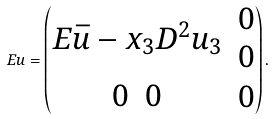<formula> <loc_0><loc_0><loc_500><loc_500>E u = \begin{pmatrix} \begin{matrix} E \bar { u } - x _ { 3 } D ^ { 2 } u _ { 3 } \end{matrix} & \begin{matrix} 0 \\ 0 \end{matrix} \\ \begin{matrix} 0 & 0 \end{matrix} & 0 \end{pmatrix} .</formula> 